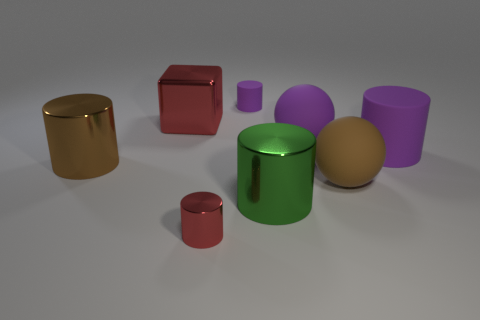Are there any other things that have the same shape as the big red object?
Your response must be concise. No. Do the tiny metallic object and the tiny rubber object have the same shape?
Ensure brevity in your answer.  Yes. Are there an equal number of big blocks in front of the big green cylinder and purple cylinders that are left of the small red metal object?
Your answer should be compact. Yes. What number of other things are the same material as the big green object?
Give a very brief answer. 3. How many large objects are either yellow matte objects or brown things?
Your answer should be very brief. 2. Are there an equal number of big brown metallic things right of the big brown metallic cylinder and purple matte balls?
Make the answer very short. No. There is a small rubber cylinder to the right of the small red cylinder; is there a rubber object that is on the right side of it?
Offer a terse response. Yes. What number of other things are the same color as the block?
Your response must be concise. 1. The big block has what color?
Make the answer very short. Red. There is a cylinder that is both to the right of the small purple object and in front of the big brown shiny cylinder; what size is it?
Your answer should be very brief. Large. 